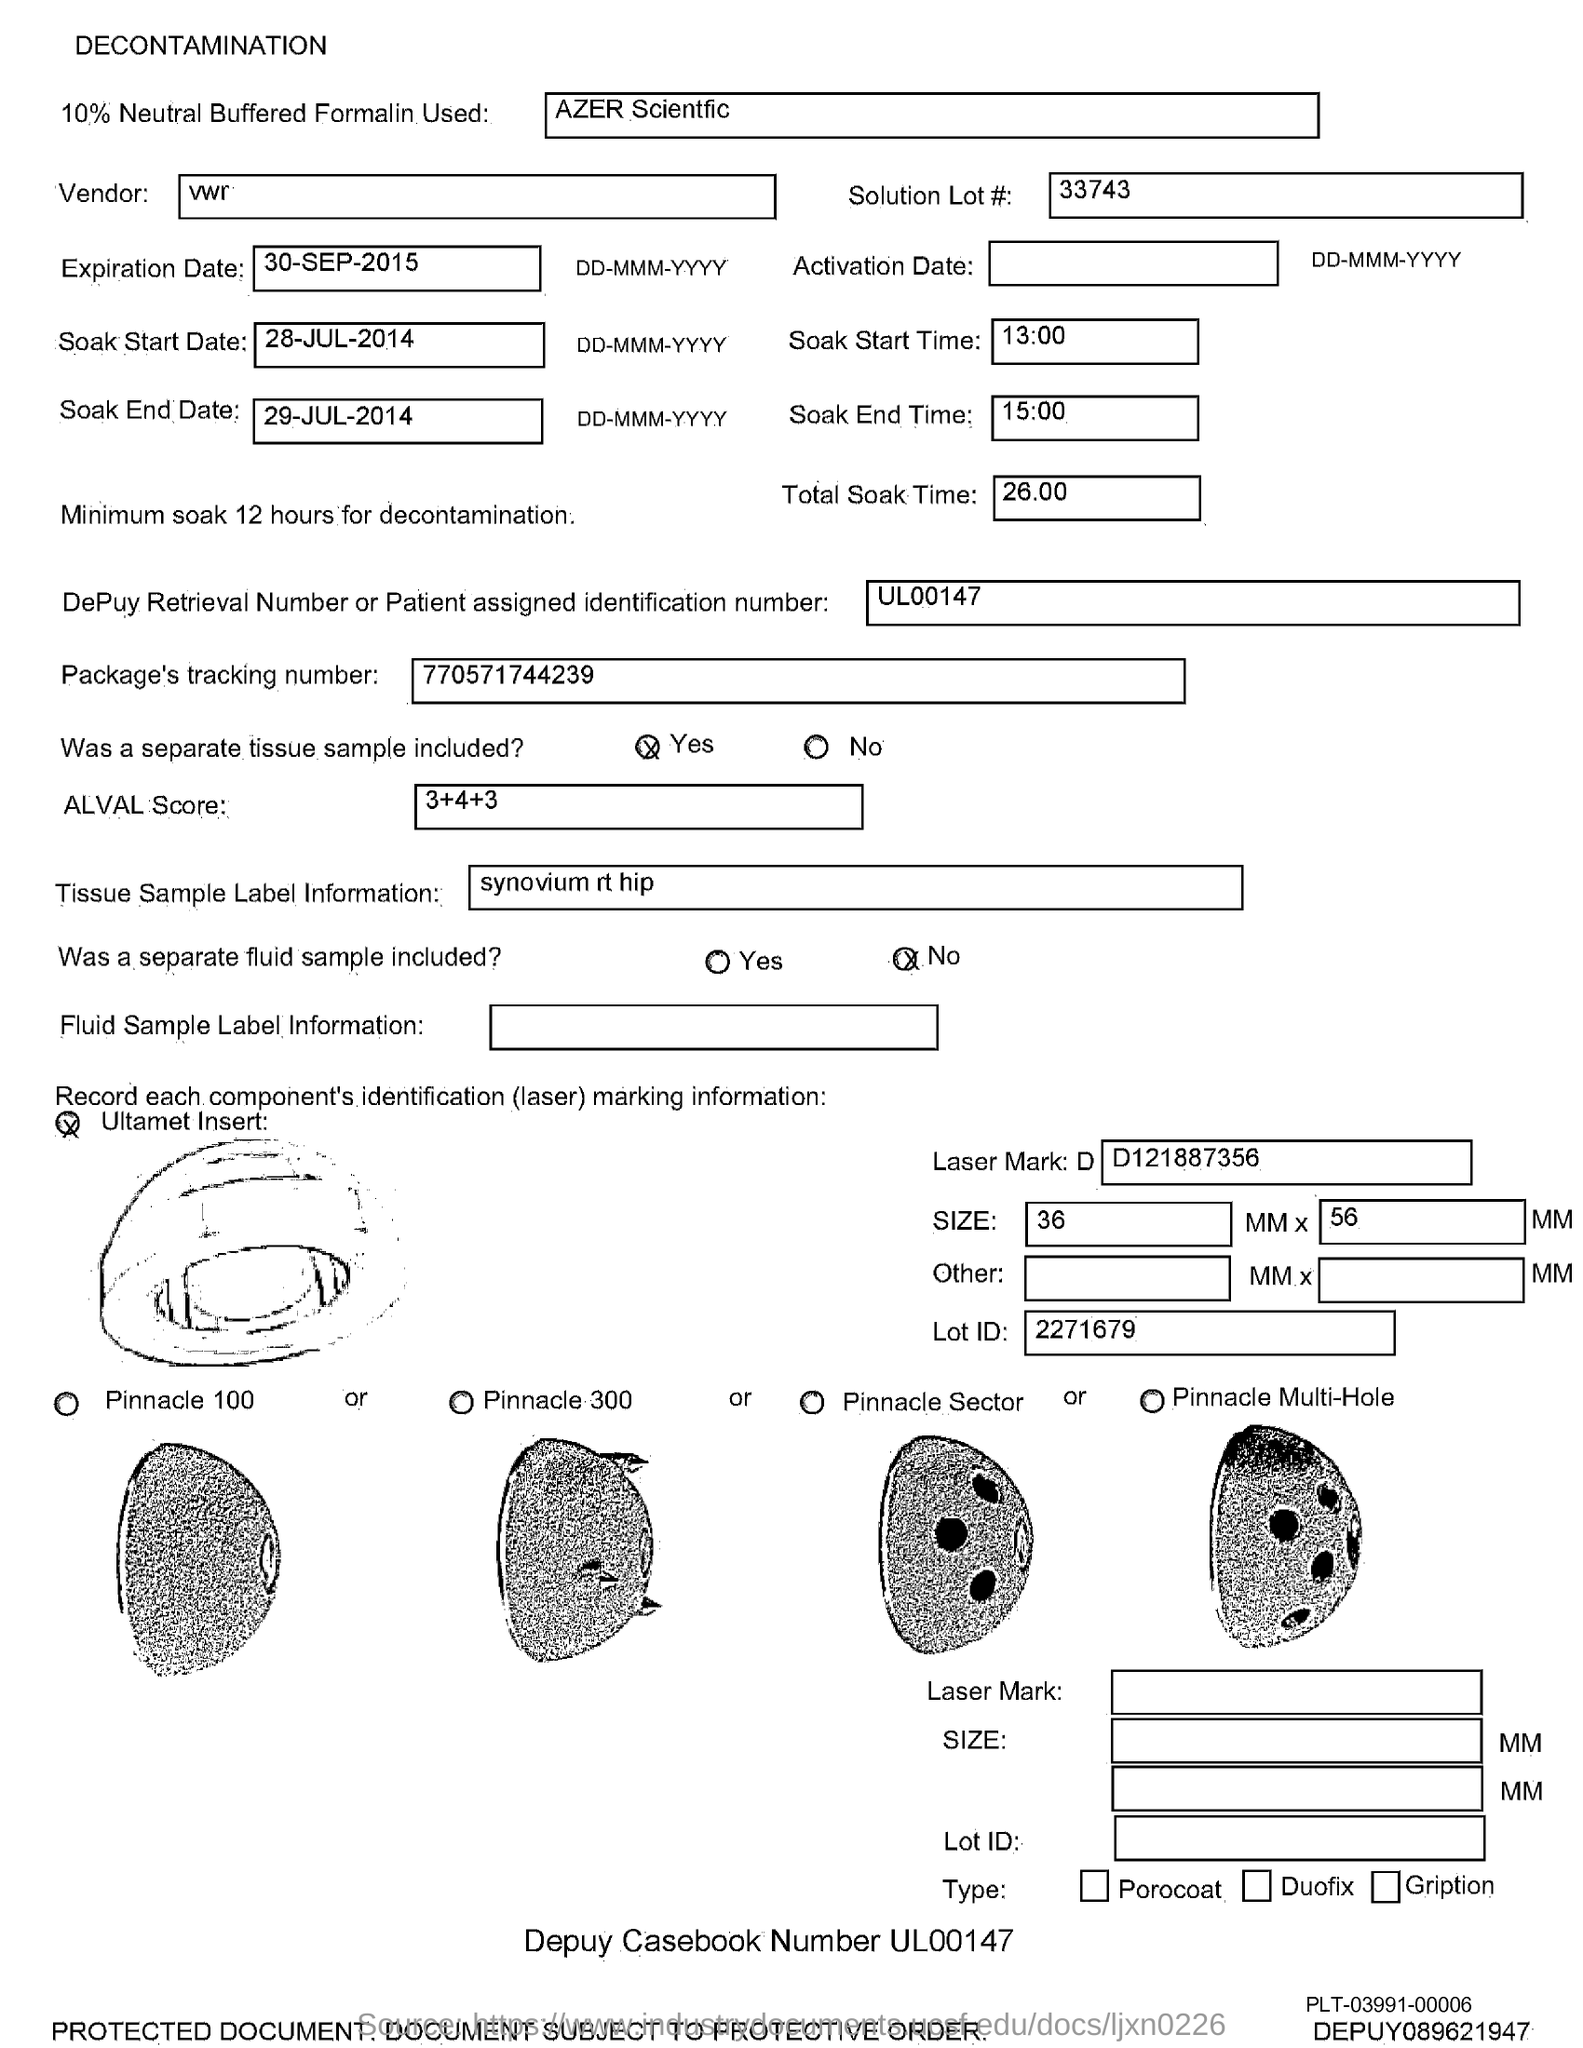Draw attention to some important aspects in this diagram. The expiration date is September 30, 2015. The ALVAL Score is a numerical value that represents the sum of a series of numbers, such as 3+4+3 in the given example. The Soak Start Date is July 28, 2014. The start time for the soak process is 13:00. The soak end date is 29-JUL-2014. 